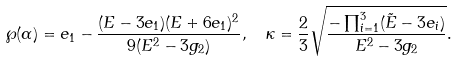<formula> <loc_0><loc_0><loc_500><loc_500>& \wp ( \alpha ) = e _ { 1 } - \frac { ( E - 3 e _ { 1 } ) ( E + 6 e _ { 1 } ) ^ { 2 } } { 9 ( E ^ { 2 } - 3 g _ { 2 } ) } , \quad \kappa = \frac { 2 } { 3 } \sqrt { \frac { - \prod _ { i = 1 } ^ { 3 } ( \tilde { E } - 3 e _ { i } ) } { E ^ { 2 } - 3 g _ { 2 } } } .</formula> 